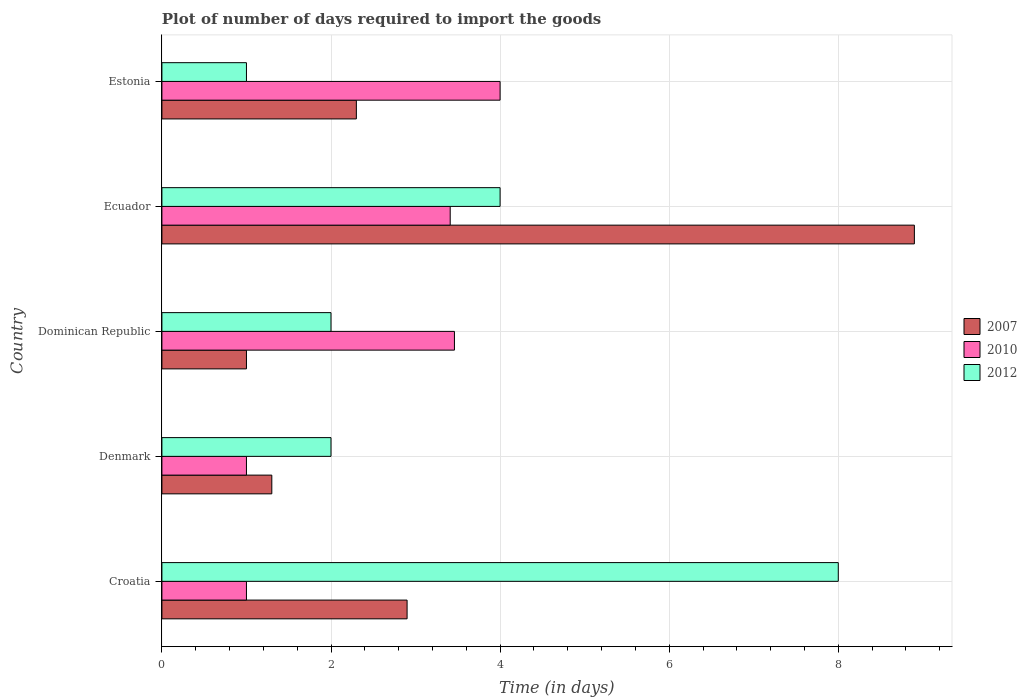How many different coloured bars are there?
Your answer should be compact. 3. Are the number of bars per tick equal to the number of legend labels?
Provide a succinct answer. Yes. How many bars are there on the 1st tick from the top?
Make the answer very short. 3. In how many cases, is the number of bars for a given country not equal to the number of legend labels?
Offer a terse response. 0. In which country was the time required to import goods in 2007 maximum?
Provide a succinct answer. Ecuador. In which country was the time required to import goods in 2007 minimum?
Offer a very short reply. Dominican Republic. What is the total time required to import goods in 2010 in the graph?
Your answer should be compact. 12.87. What is the difference between the time required to import goods in 2007 in Croatia and that in Denmark?
Offer a very short reply. 1.6. What is the difference between the time required to import goods in 2012 in Croatia and the time required to import goods in 2007 in Dominican Republic?
Make the answer very short. 7. What is the average time required to import goods in 2010 per country?
Keep it short and to the point. 2.57. What is the difference between the time required to import goods in 2010 and time required to import goods in 2007 in Estonia?
Make the answer very short. 1.7. In how many countries, is the time required to import goods in 2007 greater than 5.2 days?
Your answer should be compact. 1. What is the ratio of the time required to import goods in 2007 in Croatia to that in Estonia?
Your response must be concise. 1.26. Is the difference between the time required to import goods in 2010 in Dominican Republic and Estonia greater than the difference between the time required to import goods in 2007 in Dominican Republic and Estonia?
Ensure brevity in your answer.  Yes. In how many countries, is the time required to import goods in 2007 greater than the average time required to import goods in 2007 taken over all countries?
Your answer should be very brief. 1. Is the sum of the time required to import goods in 2007 in Dominican Republic and Ecuador greater than the maximum time required to import goods in 2010 across all countries?
Ensure brevity in your answer.  Yes. What does the 3rd bar from the top in Estonia represents?
Offer a terse response. 2007. Is it the case that in every country, the sum of the time required to import goods in 2012 and time required to import goods in 2010 is greater than the time required to import goods in 2007?
Make the answer very short. No. How many bars are there?
Provide a succinct answer. 15. How many countries are there in the graph?
Offer a terse response. 5. What is the difference between two consecutive major ticks on the X-axis?
Keep it short and to the point. 2. Where does the legend appear in the graph?
Your answer should be compact. Center right. How many legend labels are there?
Make the answer very short. 3. How are the legend labels stacked?
Keep it short and to the point. Vertical. What is the title of the graph?
Your response must be concise. Plot of number of days required to import the goods. What is the label or title of the X-axis?
Offer a terse response. Time (in days). What is the label or title of the Y-axis?
Make the answer very short. Country. What is the Time (in days) in 2007 in Croatia?
Offer a very short reply. 2.9. What is the Time (in days) of 2010 in Croatia?
Make the answer very short. 1. What is the Time (in days) of 2012 in Croatia?
Provide a succinct answer. 8. What is the Time (in days) in 2007 in Denmark?
Provide a short and direct response. 1.3. What is the Time (in days) in 2010 in Dominican Republic?
Keep it short and to the point. 3.46. What is the Time (in days) of 2010 in Ecuador?
Offer a terse response. 3.41. What is the Time (in days) of 2007 in Estonia?
Provide a short and direct response. 2.3. What is the Time (in days) in 2012 in Estonia?
Offer a very short reply. 1. Across all countries, what is the maximum Time (in days) in 2007?
Provide a succinct answer. 8.9. Across all countries, what is the maximum Time (in days) of 2012?
Offer a terse response. 8. Across all countries, what is the minimum Time (in days) in 2012?
Ensure brevity in your answer.  1. What is the total Time (in days) in 2007 in the graph?
Keep it short and to the point. 16.4. What is the total Time (in days) in 2010 in the graph?
Offer a very short reply. 12.87. What is the total Time (in days) in 2012 in the graph?
Give a very brief answer. 17. What is the difference between the Time (in days) in 2007 in Croatia and that in Denmark?
Give a very brief answer. 1.6. What is the difference between the Time (in days) of 2010 in Croatia and that in Denmark?
Your answer should be compact. 0. What is the difference between the Time (in days) in 2012 in Croatia and that in Denmark?
Provide a short and direct response. 6. What is the difference between the Time (in days) in 2007 in Croatia and that in Dominican Republic?
Give a very brief answer. 1.9. What is the difference between the Time (in days) of 2010 in Croatia and that in Dominican Republic?
Make the answer very short. -2.46. What is the difference between the Time (in days) of 2012 in Croatia and that in Dominican Republic?
Keep it short and to the point. 6. What is the difference between the Time (in days) in 2007 in Croatia and that in Ecuador?
Provide a succinct answer. -6. What is the difference between the Time (in days) in 2010 in Croatia and that in Ecuador?
Offer a terse response. -2.41. What is the difference between the Time (in days) in 2007 in Croatia and that in Estonia?
Your answer should be compact. 0.6. What is the difference between the Time (in days) in 2010 in Croatia and that in Estonia?
Offer a terse response. -3. What is the difference between the Time (in days) in 2012 in Croatia and that in Estonia?
Your answer should be compact. 7. What is the difference between the Time (in days) of 2007 in Denmark and that in Dominican Republic?
Give a very brief answer. 0.3. What is the difference between the Time (in days) in 2010 in Denmark and that in Dominican Republic?
Your response must be concise. -2.46. What is the difference between the Time (in days) of 2010 in Denmark and that in Ecuador?
Make the answer very short. -2.41. What is the difference between the Time (in days) of 2012 in Denmark and that in Ecuador?
Your response must be concise. -2. What is the difference between the Time (in days) of 2010 in Dominican Republic and that in Ecuador?
Your answer should be very brief. 0.05. What is the difference between the Time (in days) of 2007 in Dominican Republic and that in Estonia?
Offer a terse response. -1.3. What is the difference between the Time (in days) in 2010 in Dominican Republic and that in Estonia?
Offer a very short reply. -0.54. What is the difference between the Time (in days) of 2010 in Ecuador and that in Estonia?
Your answer should be compact. -0.59. What is the difference between the Time (in days) in 2012 in Ecuador and that in Estonia?
Keep it short and to the point. 3. What is the difference between the Time (in days) of 2007 in Croatia and the Time (in days) of 2012 in Denmark?
Offer a terse response. 0.9. What is the difference between the Time (in days) of 2010 in Croatia and the Time (in days) of 2012 in Denmark?
Offer a terse response. -1. What is the difference between the Time (in days) in 2007 in Croatia and the Time (in days) in 2010 in Dominican Republic?
Your answer should be compact. -0.56. What is the difference between the Time (in days) in 2007 in Croatia and the Time (in days) in 2010 in Ecuador?
Provide a short and direct response. -0.51. What is the difference between the Time (in days) in 2010 in Croatia and the Time (in days) in 2012 in Ecuador?
Your answer should be compact. -3. What is the difference between the Time (in days) in 2007 in Croatia and the Time (in days) in 2010 in Estonia?
Give a very brief answer. -1.1. What is the difference between the Time (in days) in 2007 in Denmark and the Time (in days) in 2010 in Dominican Republic?
Offer a very short reply. -2.16. What is the difference between the Time (in days) in 2007 in Denmark and the Time (in days) in 2010 in Ecuador?
Your answer should be very brief. -2.11. What is the difference between the Time (in days) of 2007 in Dominican Republic and the Time (in days) of 2010 in Ecuador?
Your response must be concise. -2.41. What is the difference between the Time (in days) in 2010 in Dominican Republic and the Time (in days) in 2012 in Ecuador?
Offer a terse response. -0.54. What is the difference between the Time (in days) of 2010 in Dominican Republic and the Time (in days) of 2012 in Estonia?
Ensure brevity in your answer.  2.46. What is the difference between the Time (in days) in 2010 in Ecuador and the Time (in days) in 2012 in Estonia?
Your answer should be very brief. 2.41. What is the average Time (in days) in 2007 per country?
Give a very brief answer. 3.28. What is the average Time (in days) in 2010 per country?
Make the answer very short. 2.57. What is the average Time (in days) in 2012 per country?
Make the answer very short. 3.4. What is the difference between the Time (in days) of 2007 and Time (in days) of 2010 in Croatia?
Keep it short and to the point. 1.9. What is the difference between the Time (in days) in 2007 and Time (in days) in 2012 in Denmark?
Your response must be concise. -0.7. What is the difference between the Time (in days) of 2010 and Time (in days) of 2012 in Denmark?
Offer a very short reply. -1. What is the difference between the Time (in days) of 2007 and Time (in days) of 2010 in Dominican Republic?
Provide a short and direct response. -2.46. What is the difference between the Time (in days) of 2010 and Time (in days) of 2012 in Dominican Republic?
Offer a very short reply. 1.46. What is the difference between the Time (in days) of 2007 and Time (in days) of 2010 in Ecuador?
Ensure brevity in your answer.  5.49. What is the difference between the Time (in days) in 2007 and Time (in days) in 2012 in Ecuador?
Your response must be concise. 4.9. What is the difference between the Time (in days) in 2010 and Time (in days) in 2012 in Ecuador?
Provide a succinct answer. -0.59. What is the difference between the Time (in days) in 2007 and Time (in days) in 2012 in Estonia?
Keep it short and to the point. 1.3. What is the ratio of the Time (in days) in 2007 in Croatia to that in Denmark?
Give a very brief answer. 2.23. What is the ratio of the Time (in days) in 2010 in Croatia to that in Denmark?
Keep it short and to the point. 1. What is the ratio of the Time (in days) of 2012 in Croatia to that in Denmark?
Keep it short and to the point. 4. What is the ratio of the Time (in days) in 2010 in Croatia to that in Dominican Republic?
Keep it short and to the point. 0.29. What is the ratio of the Time (in days) in 2012 in Croatia to that in Dominican Republic?
Make the answer very short. 4. What is the ratio of the Time (in days) in 2007 in Croatia to that in Ecuador?
Give a very brief answer. 0.33. What is the ratio of the Time (in days) in 2010 in Croatia to that in Ecuador?
Provide a succinct answer. 0.29. What is the ratio of the Time (in days) in 2012 in Croatia to that in Ecuador?
Your response must be concise. 2. What is the ratio of the Time (in days) in 2007 in Croatia to that in Estonia?
Your response must be concise. 1.26. What is the ratio of the Time (in days) in 2010 in Croatia to that in Estonia?
Make the answer very short. 0.25. What is the ratio of the Time (in days) in 2010 in Denmark to that in Dominican Republic?
Give a very brief answer. 0.29. What is the ratio of the Time (in days) in 2012 in Denmark to that in Dominican Republic?
Make the answer very short. 1. What is the ratio of the Time (in days) in 2007 in Denmark to that in Ecuador?
Your response must be concise. 0.15. What is the ratio of the Time (in days) of 2010 in Denmark to that in Ecuador?
Make the answer very short. 0.29. What is the ratio of the Time (in days) in 2012 in Denmark to that in Ecuador?
Offer a very short reply. 0.5. What is the ratio of the Time (in days) of 2007 in Denmark to that in Estonia?
Provide a short and direct response. 0.57. What is the ratio of the Time (in days) in 2010 in Denmark to that in Estonia?
Make the answer very short. 0.25. What is the ratio of the Time (in days) of 2012 in Denmark to that in Estonia?
Offer a very short reply. 2. What is the ratio of the Time (in days) of 2007 in Dominican Republic to that in Ecuador?
Your response must be concise. 0.11. What is the ratio of the Time (in days) of 2010 in Dominican Republic to that in Ecuador?
Offer a very short reply. 1.01. What is the ratio of the Time (in days) in 2012 in Dominican Republic to that in Ecuador?
Offer a terse response. 0.5. What is the ratio of the Time (in days) of 2007 in Dominican Republic to that in Estonia?
Your response must be concise. 0.43. What is the ratio of the Time (in days) of 2010 in Dominican Republic to that in Estonia?
Provide a succinct answer. 0.86. What is the ratio of the Time (in days) in 2007 in Ecuador to that in Estonia?
Your answer should be compact. 3.87. What is the ratio of the Time (in days) in 2010 in Ecuador to that in Estonia?
Provide a succinct answer. 0.85. What is the difference between the highest and the second highest Time (in days) of 2010?
Give a very brief answer. 0.54. What is the difference between the highest and the lowest Time (in days) of 2012?
Offer a terse response. 7. 